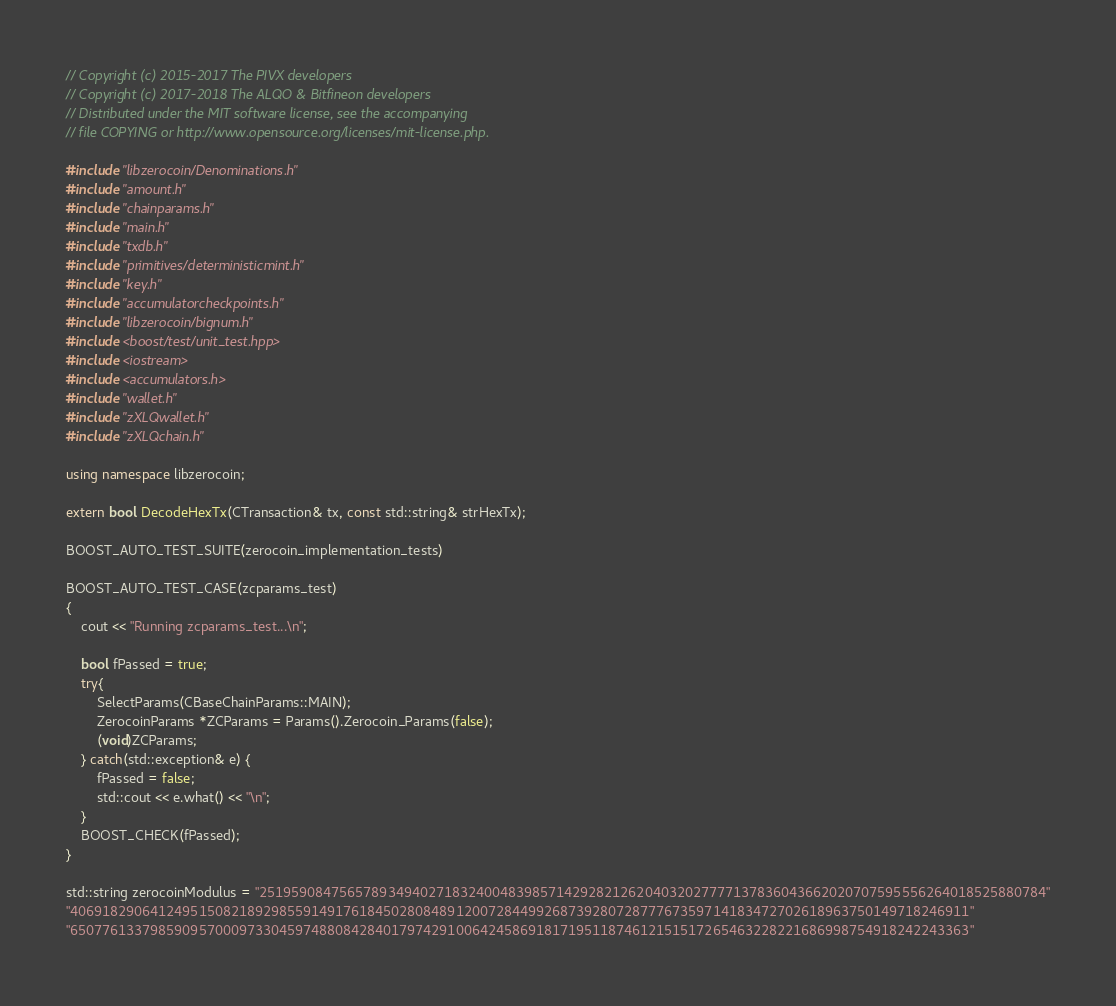Convert code to text. <code><loc_0><loc_0><loc_500><loc_500><_C++_>// Copyright (c) 2015-2017 The PIVX developers// Copyright (c) 2017-2018 The ALQO & Bitfineon developers
// Distributed under the MIT software license, see the accompanying
// file COPYING or http://www.opensource.org/licenses/mit-license.php.

#include "libzerocoin/Denominations.h"
#include "amount.h"
#include "chainparams.h"
#include "main.h"
#include "txdb.h"
#include "primitives/deterministicmint.h"
#include "key.h"
#include "accumulatorcheckpoints.h"
#include "libzerocoin/bignum.h"
#include <boost/test/unit_test.hpp>
#include <iostream>
#include <accumulators.h>
#include "wallet.h"
#include "zXLQwallet.h"
#include "zXLQchain.h"

using namespace libzerocoin;

extern bool DecodeHexTx(CTransaction& tx, const std::string& strHexTx);

BOOST_AUTO_TEST_SUITE(zerocoin_implementation_tests)

BOOST_AUTO_TEST_CASE(zcparams_test)
{
    cout << "Running zcparams_test...\n";

    bool fPassed = true;
    try{
        SelectParams(CBaseChainParams::MAIN);
        ZerocoinParams *ZCParams = Params().Zerocoin_Params(false);
        (void)ZCParams;
    } catch(std::exception& e) {
        fPassed = false;
        std::cout << e.what() << "\n";
    }
    BOOST_CHECK(fPassed);
}

std::string zerocoinModulus = "25195908475657893494027183240048398571429282126204032027777137836043662020707595556264018525880784"
"4069182906412495150821892985591491761845028084891200728449926873928072877767359714183472702618963750149718246911"
"6507761337985909570009733045974880842840179742910064245869181719511874612151517265463228221686998754918242243363"</code> 